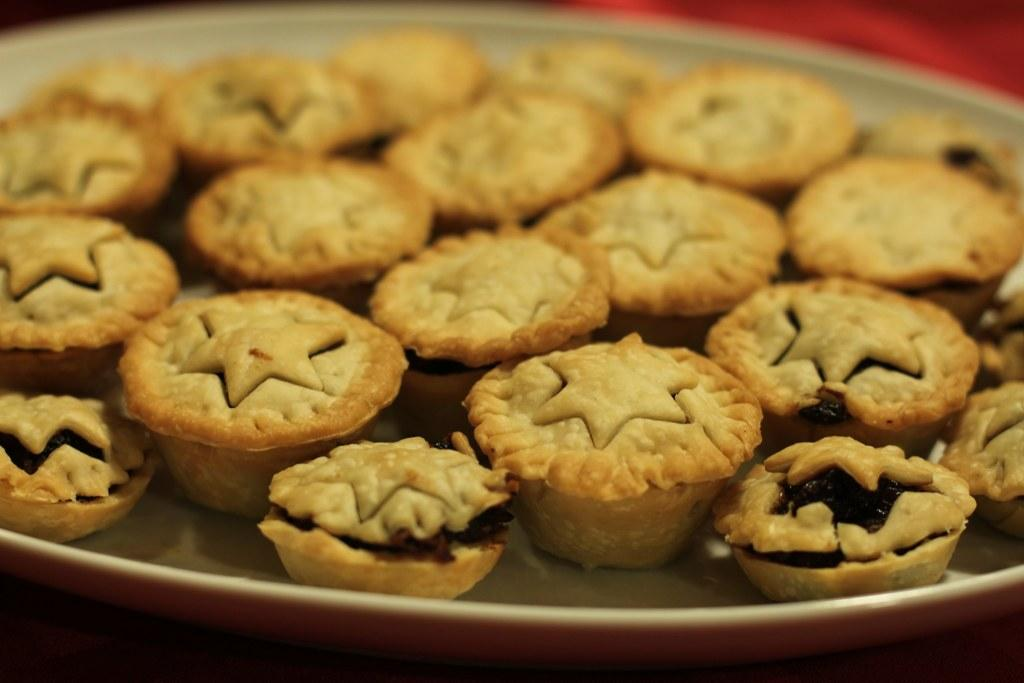What type of food can be seen in the image? There are cookies in the image. How are the cookies arranged in the image? The cookies are in a plate. Where is the plate with cookies located? The plate is placed on a surface. What is the current hour according to the clock in the image? There is no clock present in the image, so it is not possible to determine the current hour. 